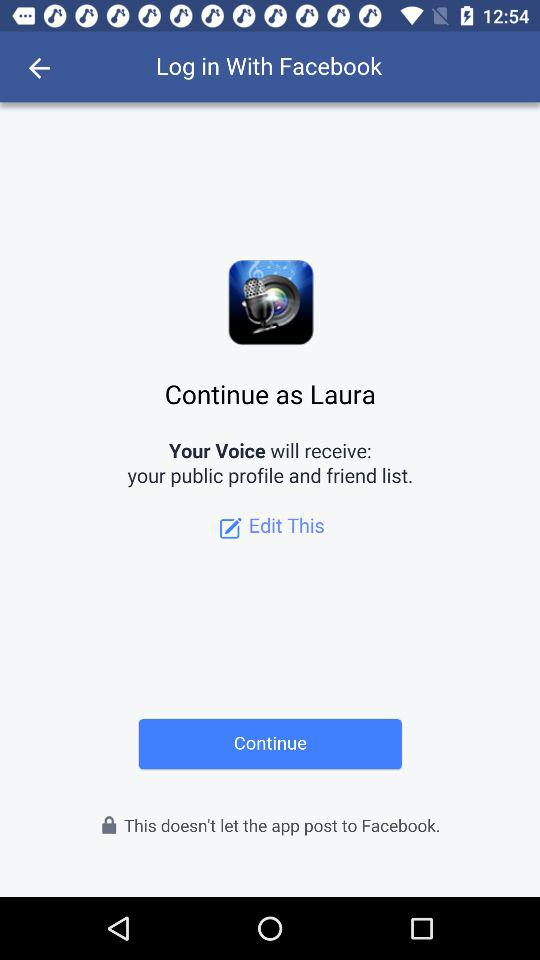What is the user name? The user name is Laura. 